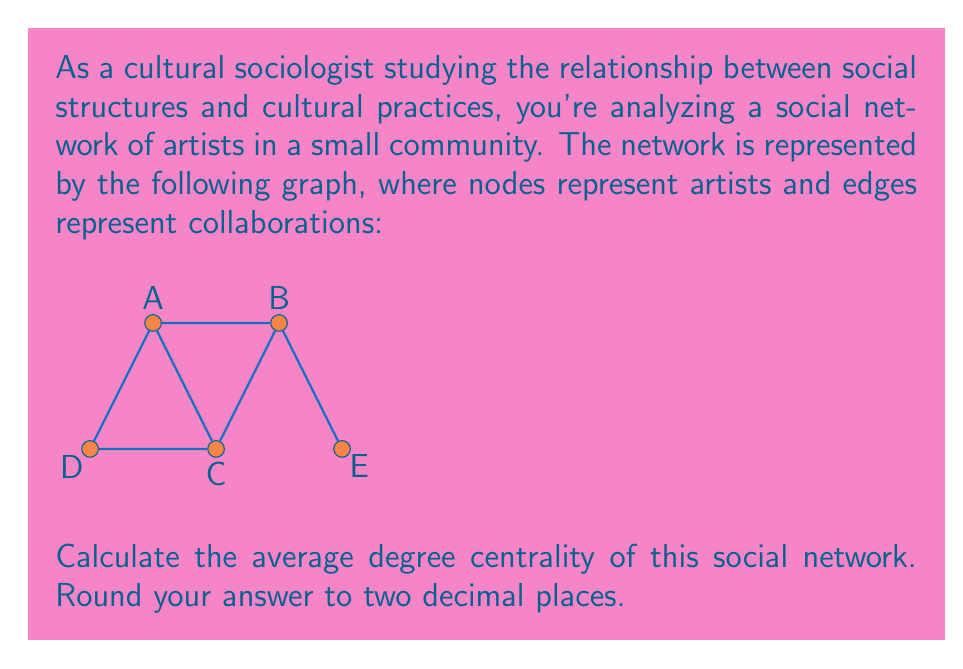Can you solve this math problem? To solve this problem, we'll follow these steps:

1) First, let's understand what degree centrality means. In a social network, the degree centrality of a node is the number of direct connections (edges) it has to other nodes.

2) We need to calculate the degree centrality for each node:

   Node A: 3 connections (to B, C, and D)
   Node B: 3 connections (to A, C, and E)
   Node C: 3 connections (to A, B, and D)
   Node D: 2 connections (to A and C)
   Node E: 1 connection (to B)

3) Now, we need to calculate the average. The formula for average is:

   $$ \text{Average} = \frac{\sum \text{values}}{\text{number of values}} $$

4) In this case:

   $$ \text{Average Degree Centrality} = \frac{3 + 3 + 3 + 2 + 1}{5} = \frac{12}{5} = 2.4 $$

5) The question asks for the answer rounded to two decimal places, which is already the case here.

This average degree centrality provides insight into the overall connectivity of the network. A higher average indicates a more densely connected network, which could suggest more collaboration and information sharing among the artists in this community.
Answer: 2.40 